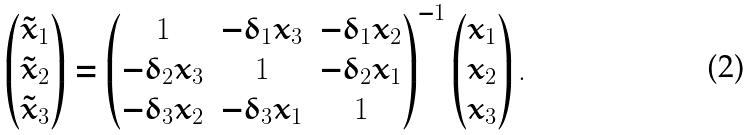Convert formula to latex. <formula><loc_0><loc_0><loc_500><loc_500>\begin{pmatrix} \tilde { x } _ { 1 } \\ \tilde { x } _ { 2 } \\ \tilde { x } _ { 3 } \end{pmatrix} = \begin{pmatrix} 1 & - \delta _ { 1 } x _ { 3 } & - \delta _ { 1 } x _ { 2 } \\ - \delta _ { 2 } x _ { 3 } & 1 & - \delta _ { 2 } x _ { 1 } \\ - \delta _ { 3 } x _ { 2 } & - \delta _ { 3 } x _ { 1 } & 1 \end{pmatrix} ^ { - 1 } \begin{pmatrix} x _ { 1 } \\ x _ { 2 } \\ x _ { 3 } \end{pmatrix} .</formula> 